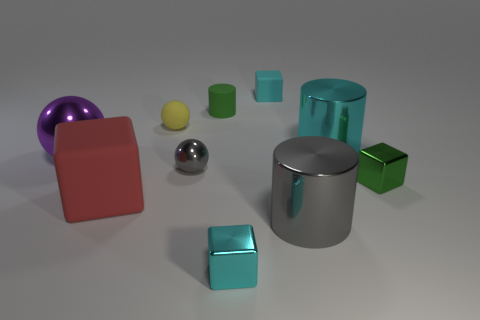Subtract 1 spheres. How many spheres are left? 2 Subtract all brown blocks. Subtract all purple spheres. How many blocks are left? 4 Subtract all cylinders. How many objects are left? 7 Add 2 tiny objects. How many tiny objects exist? 8 Subtract 0 blue blocks. How many objects are left? 10 Subtract all cyan metal cylinders. Subtract all large cyan metallic cylinders. How many objects are left? 8 Add 1 cyan cubes. How many cyan cubes are left? 3 